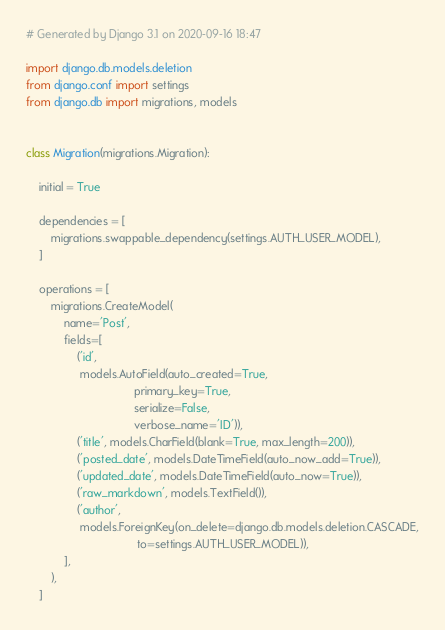Convert code to text. <code><loc_0><loc_0><loc_500><loc_500><_Python_># Generated by Django 3.1 on 2020-09-16 18:47

import django.db.models.deletion
from django.conf import settings
from django.db import migrations, models


class Migration(migrations.Migration):

    initial = True

    dependencies = [
        migrations.swappable_dependency(settings.AUTH_USER_MODEL),
    ]

    operations = [
        migrations.CreateModel(
            name='Post',
            fields=[
                ('id',
                 models.AutoField(auto_created=True,
                                  primary_key=True,
                                  serialize=False,
                                  verbose_name='ID')),
                ('title', models.CharField(blank=True, max_length=200)),
                ('posted_date', models.DateTimeField(auto_now_add=True)),
                ('updated_date', models.DateTimeField(auto_now=True)),
                ('raw_markdown', models.TextField()),
                ('author',
                 models.ForeignKey(on_delete=django.db.models.deletion.CASCADE,
                                   to=settings.AUTH_USER_MODEL)),
            ],
        ),
    ]
</code> 